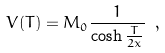<formula> <loc_0><loc_0><loc_500><loc_500>V ( T ) = M _ { 0 } \frac { 1 } { \cosh \frac { T } { 2 x } } \ ,</formula> 